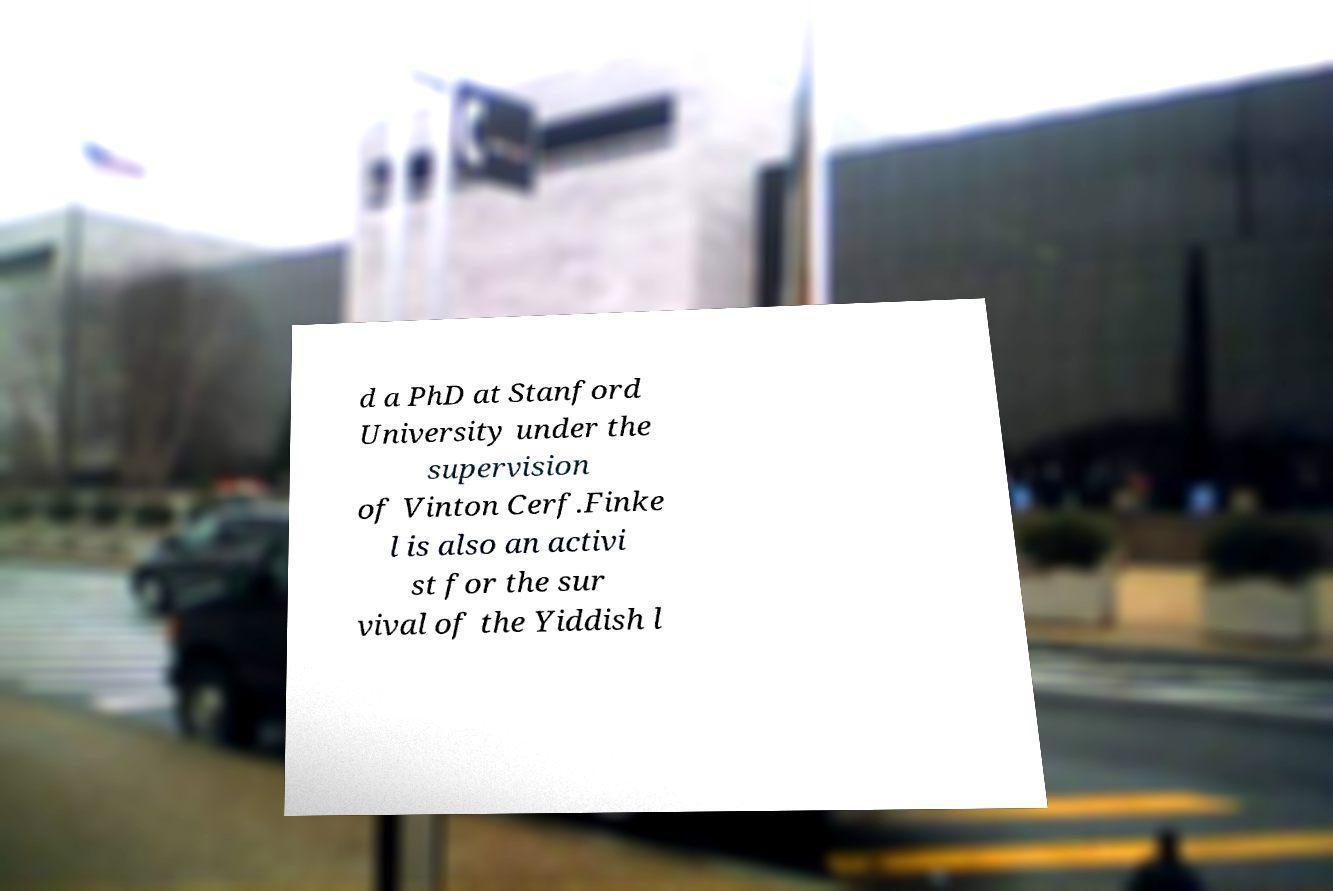For documentation purposes, I need the text within this image transcribed. Could you provide that? d a PhD at Stanford University under the supervision of Vinton Cerf.Finke l is also an activi st for the sur vival of the Yiddish l 